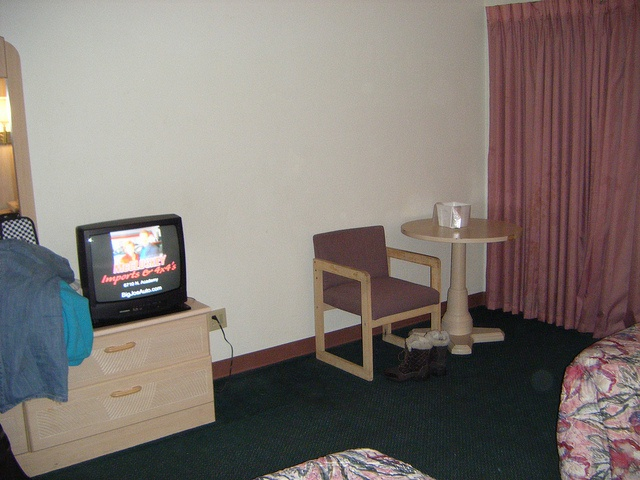Describe the objects in this image and their specific colors. I can see chair in gray, maroon, and black tones, bed in gray, darkgray, and black tones, couch in gray and darkgray tones, tv in gray, black, white, and lightpink tones, and dining table in gray and darkgray tones in this image. 